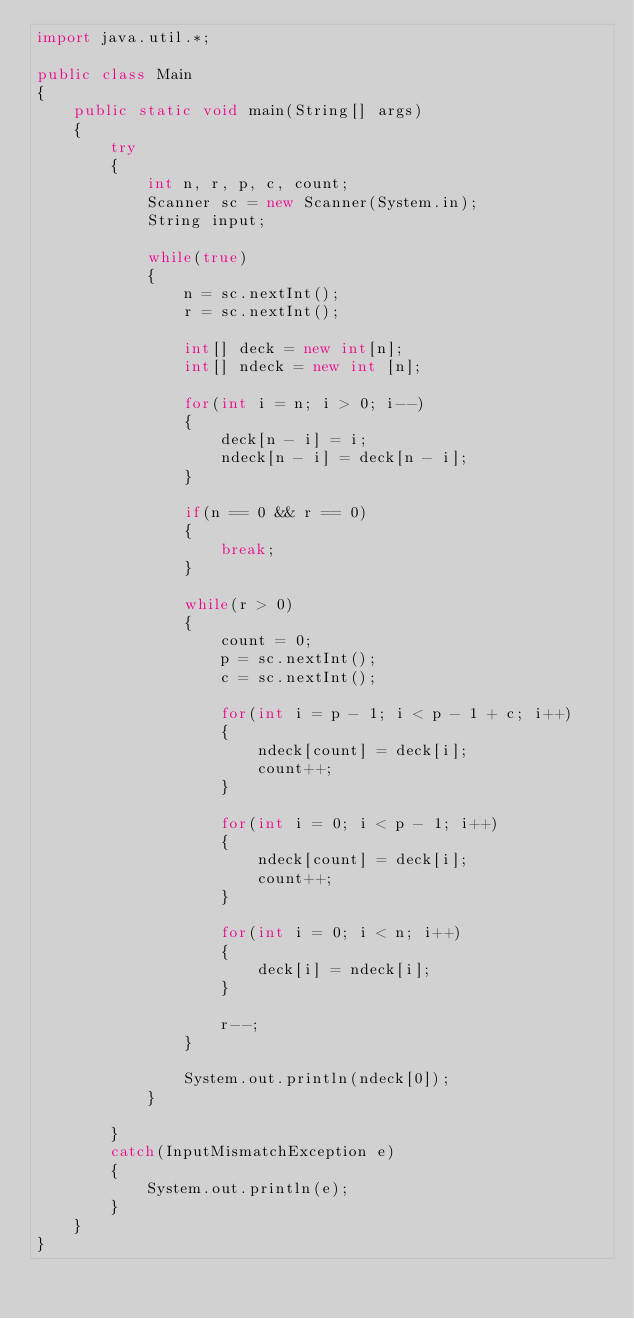Convert code to text. <code><loc_0><loc_0><loc_500><loc_500><_Java_>import java.util.*;

public class Main
{
	public static void main(String[] args)
	{
		try
		{
			int n, r, p, c, count;
			Scanner sc = new Scanner(System.in);
			String input;

			while(true)
			{
				n = sc.nextInt();
				r = sc.nextInt();

				int[] deck = new int[n];
				int[] ndeck = new int [n];

				for(int i = n; i > 0; i--)
				{
					deck[n - i] = i;
					ndeck[n - i] = deck[n - i];
				}

				if(n == 0 && r == 0)
				{
					break;
				}

				while(r > 0)
				{
					count = 0;
					p = sc.nextInt();
					c = sc.nextInt();

					for(int i = p - 1; i < p - 1 + c; i++)
					{
						ndeck[count] = deck[i];
						count++;
					}

					for(int i = 0; i < p - 1; i++)
					{
						ndeck[count] = deck[i];
						count++;
					}

					for(int i = 0; i < n; i++)
					{
						deck[i] = ndeck[i];
					}

					r--;
				}

				System.out.println(ndeck[0]);
			}

		}
		catch(InputMismatchException e)
		{
			System.out.println(e);
		}
	}
}</code> 